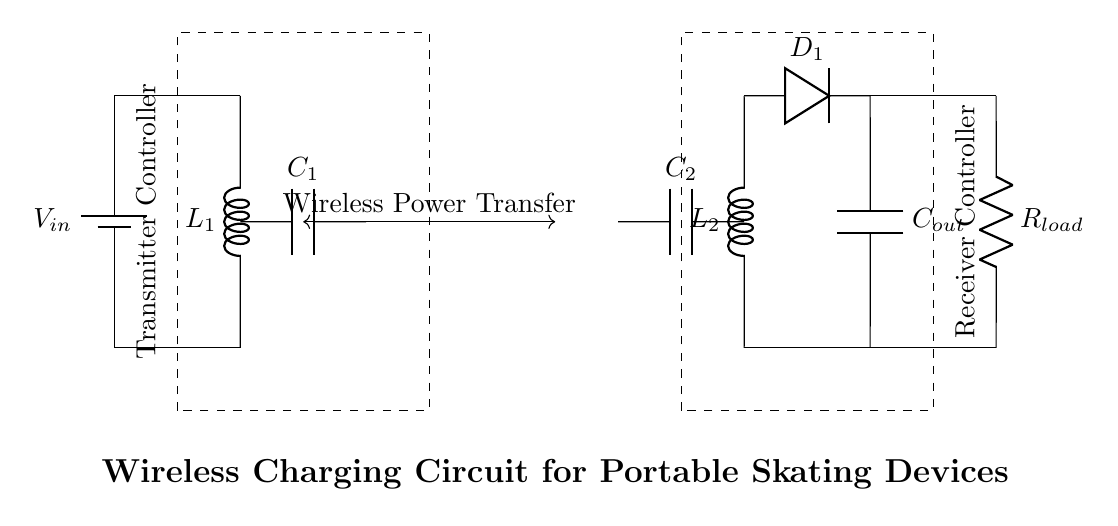What is the input voltage for the circuit? The input voltage is specified as V sub in, which represents the power source connected to the transmitter section of the circuit.
Answer: V in What components are used in the transmitter section? The transmitter section consists of a battery, an inductor labeled L sub 1, and a capacitor labeled C sub 1 connected in series.
Answer: Battery, L1, C1 What does the load consist of? The load is comprised of a resistor labeled R sub load, which is connected to the output of the receiver circuit.
Answer: R load How many capacitors are present in the entire circuit? There are two capacitors in the circuit: C sub 1 in the transmitter and C sub 2 in the receiver section.
Answer: 2 What type of power transfer is indicated in the circuit? The circuit employs Wireless Power Transfer, which indicates that power is transmitted through an electromagnetic field rather than through direct electrical connections.
Answer: Wireless Power Transfer Which components are used in the receiver section? The receiver section includes a capacitor C sub 2, an inductor L sub 2, a diode D sub 1, and another capacitor labeled C sub out, in addition to the load resistor.
Answer: C2, L2, D1, C out 